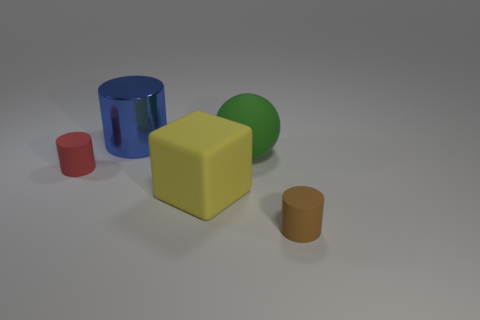What number of large blue metal objects are the same shape as the green thing?
Keep it short and to the point. 0. There is another object that is the same size as the red rubber thing; what material is it?
Provide a succinct answer. Rubber. Are there any blue things of the same size as the green matte thing?
Your answer should be compact. Yes. Are there fewer large green spheres on the right side of the brown rubber cylinder than big yellow matte objects?
Offer a terse response. Yes. Is the number of big rubber cubes that are in front of the small brown thing less than the number of tiny matte objects to the right of the green thing?
Your response must be concise. Yes. How many balls are tiny red rubber objects or matte things?
Your response must be concise. 1. Does the large yellow block on the right side of the tiny red cylinder have the same material as the tiny object that is right of the big green thing?
Ensure brevity in your answer.  Yes. There is a green thing that is the same size as the metallic cylinder; what is its shape?
Provide a succinct answer. Sphere. What number of brown things are either large blocks or small matte things?
Make the answer very short. 1. There is a small rubber thing that is to the right of the big blue metal object; does it have the same shape as the tiny object that is left of the block?
Give a very brief answer. Yes. 